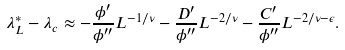<formula> <loc_0><loc_0><loc_500><loc_500>\lambda _ { L } ^ { \ast } - \lambda _ { c } \approx - \frac { \phi ^ { \prime } } { \phi ^ { \prime \prime } } L ^ { - 1 / \nu } - \frac { D ^ { \prime } } { \phi ^ { \prime \prime } } L ^ { - 2 / \nu } - \frac { C ^ { \prime } } { \phi ^ { \prime \prime } } L ^ { - 2 / \nu - \epsilon } .</formula> 